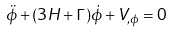Convert formula to latex. <formula><loc_0><loc_0><loc_500><loc_500>\ddot { \phi } + ( 3 H + \Gamma ) \dot { \phi } + V _ { , \phi } = 0</formula> 